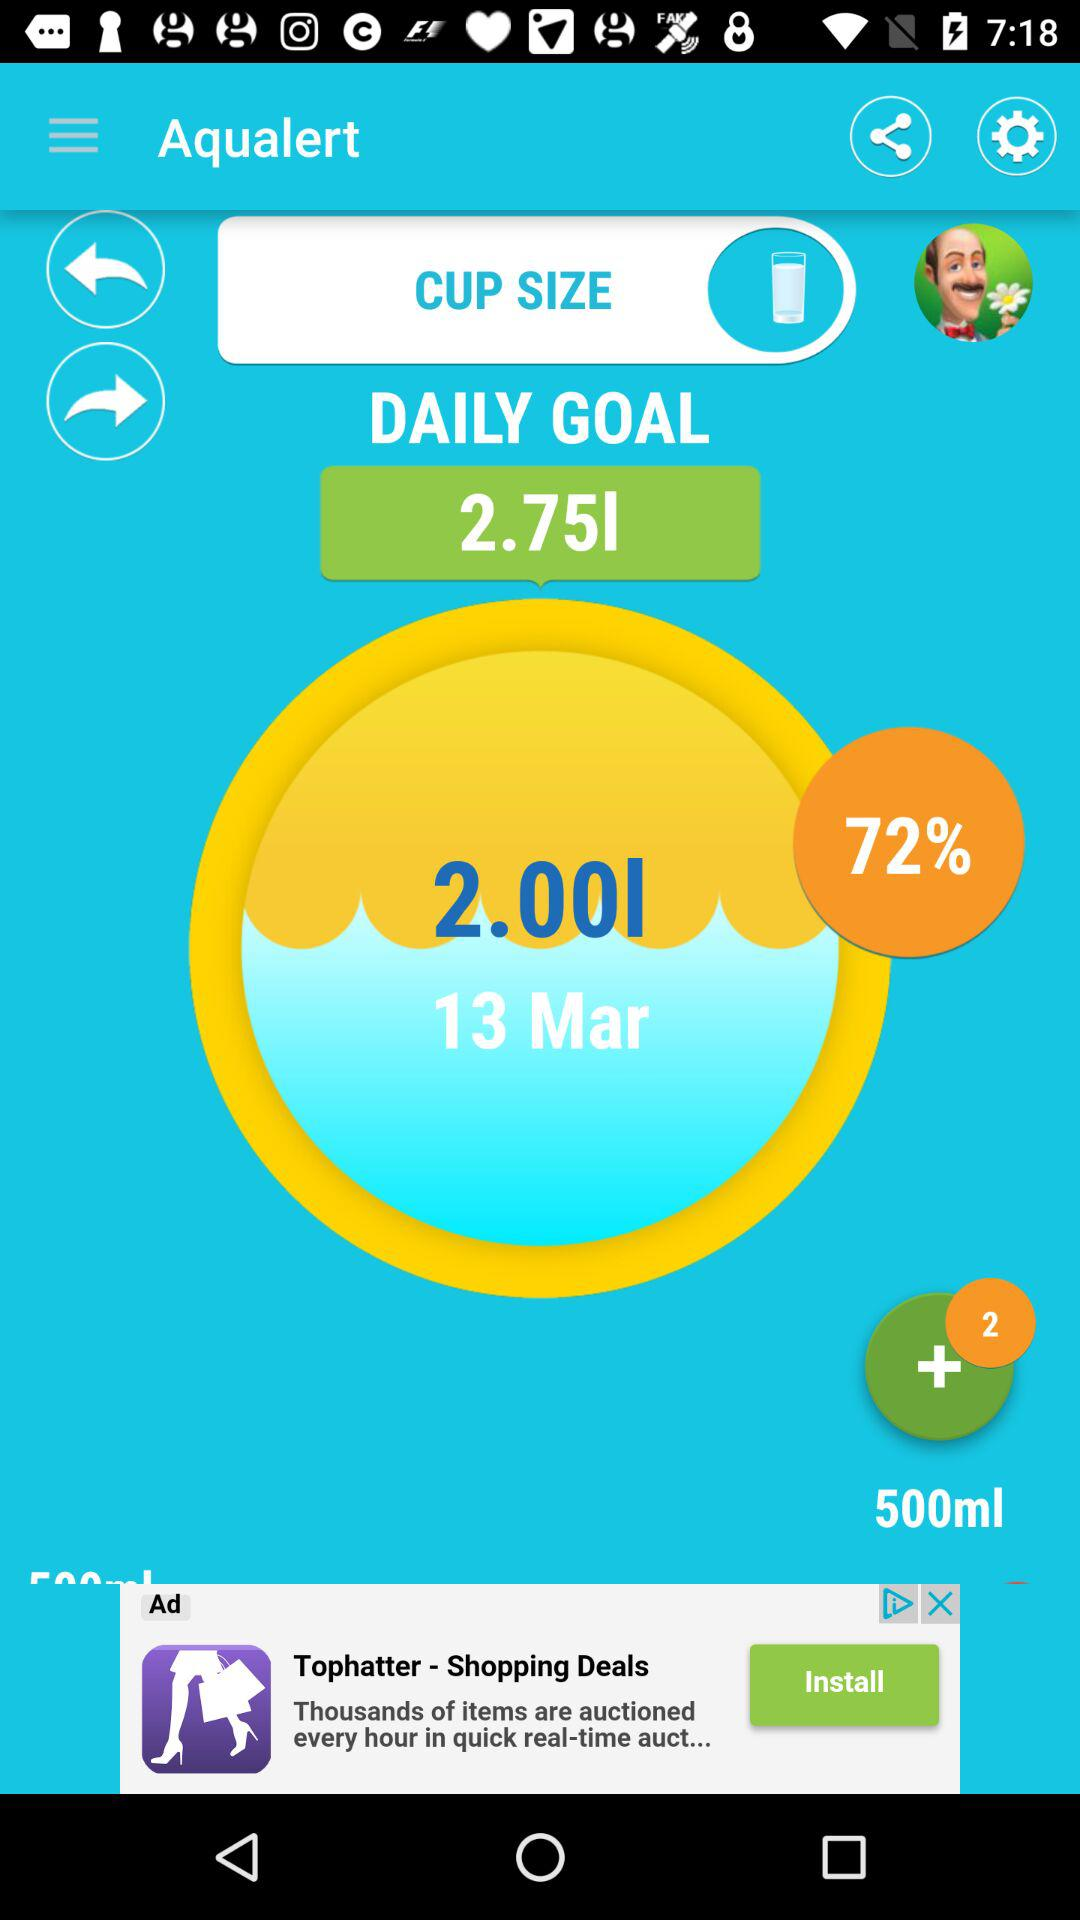How much of the goal has been achieved for March 13? For March 13, 72% of the goal has been achieved. 